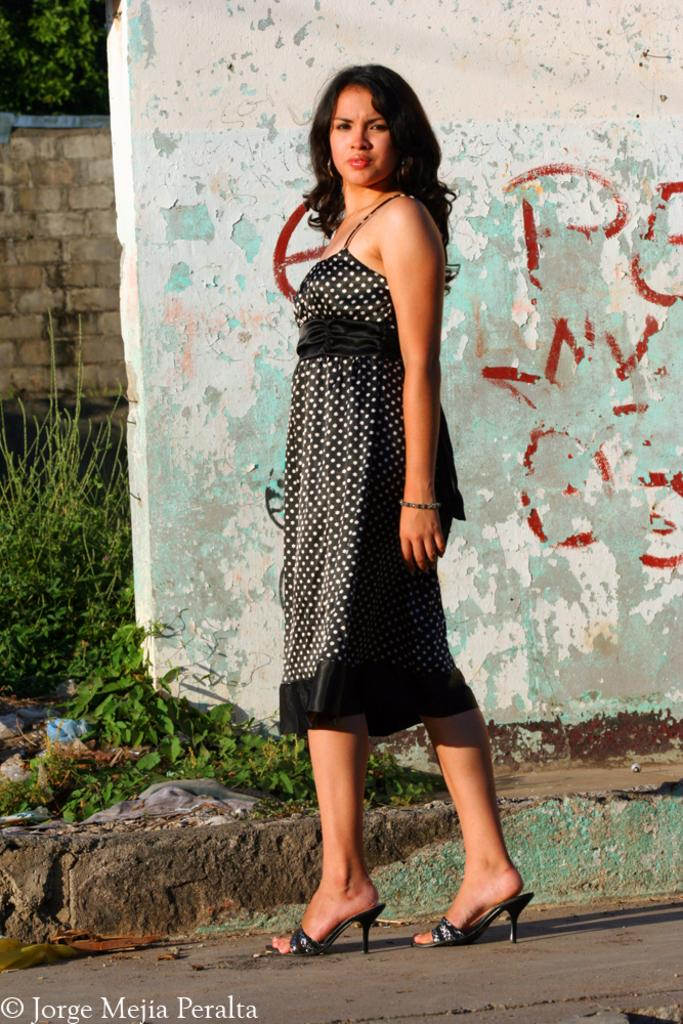What is present in the image? There is a person, a road, a path, plants, trees, walls, and a watermark on the bottom left side of the image. Can you describe the person in the image? The facts provided do not give any details about the person's appearance or actions. What type of path is visible in the image? The facts provided do not specify the type of path, but it is visible in the image. What can be seen in the background of the image? In the background of the image, there are plants, trees, and walls. What type of writing can be seen on the trees in the image? There is no writing present on the trees in the image. How many dimes are visible on the path in the image? There are no dimes visible on the path in the image. 